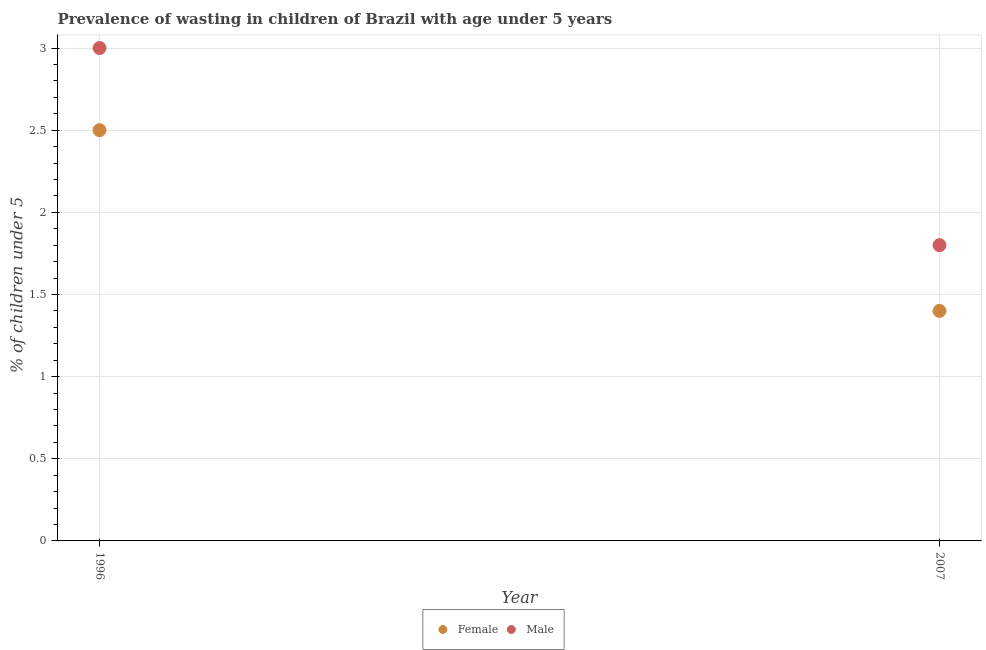How many different coloured dotlines are there?
Keep it short and to the point. 2. Across all years, what is the maximum percentage of undernourished male children?
Your answer should be very brief. 3. Across all years, what is the minimum percentage of undernourished male children?
Keep it short and to the point. 1.8. What is the total percentage of undernourished male children in the graph?
Offer a terse response. 4.8. What is the difference between the percentage of undernourished female children in 1996 and that in 2007?
Your answer should be very brief. 1.1. What is the difference between the percentage of undernourished male children in 2007 and the percentage of undernourished female children in 1996?
Make the answer very short. -0.7. What is the average percentage of undernourished male children per year?
Provide a succinct answer. 2.4. In the year 2007, what is the difference between the percentage of undernourished male children and percentage of undernourished female children?
Your answer should be very brief. 0.4. What is the ratio of the percentage of undernourished female children in 1996 to that in 2007?
Provide a succinct answer. 1.79. Is the percentage of undernourished female children in 1996 less than that in 2007?
Provide a succinct answer. No. In how many years, is the percentage of undernourished female children greater than the average percentage of undernourished female children taken over all years?
Offer a terse response. 1. Does the percentage of undernourished male children monotonically increase over the years?
Keep it short and to the point. No. Is the percentage of undernourished female children strictly greater than the percentage of undernourished male children over the years?
Ensure brevity in your answer.  No. Is the percentage of undernourished male children strictly less than the percentage of undernourished female children over the years?
Keep it short and to the point. No. How many dotlines are there?
Make the answer very short. 2. How many years are there in the graph?
Provide a short and direct response. 2. What is the difference between two consecutive major ticks on the Y-axis?
Your response must be concise. 0.5. Are the values on the major ticks of Y-axis written in scientific E-notation?
Ensure brevity in your answer.  No. Does the graph contain any zero values?
Your answer should be very brief. No. Does the graph contain grids?
Provide a succinct answer. Yes. Where does the legend appear in the graph?
Ensure brevity in your answer.  Bottom center. What is the title of the graph?
Make the answer very short. Prevalence of wasting in children of Brazil with age under 5 years. Does "Public funds" appear as one of the legend labels in the graph?
Your answer should be compact. No. What is the label or title of the X-axis?
Your response must be concise. Year. What is the label or title of the Y-axis?
Give a very brief answer.  % of children under 5. What is the  % of children under 5 in Female in 1996?
Make the answer very short. 2.5. What is the  % of children under 5 of Female in 2007?
Offer a terse response. 1.4. What is the  % of children under 5 of Male in 2007?
Your answer should be very brief. 1.8. Across all years, what is the maximum  % of children under 5 of Female?
Make the answer very short. 2.5. Across all years, what is the minimum  % of children under 5 of Female?
Give a very brief answer. 1.4. Across all years, what is the minimum  % of children under 5 in Male?
Provide a short and direct response. 1.8. What is the total  % of children under 5 in Female in the graph?
Offer a terse response. 3.9. What is the total  % of children under 5 of Male in the graph?
Give a very brief answer. 4.8. What is the difference between the  % of children under 5 of Male in 1996 and that in 2007?
Ensure brevity in your answer.  1.2. What is the difference between the  % of children under 5 of Female in 1996 and the  % of children under 5 of Male in 2007?
Give a very brief answer. 0.7. What is the average  % of children under 5 of Female per year?
Your answer should be compact. 1.95. What is the ratio of the  % of children under 5 of Female in 1996 to that in 2007?
Provide a succinct answer. 1.79. What is the difference between the highest and the second highest  % of children under 5 in Male?
Your answer should be compact. 1.2. 